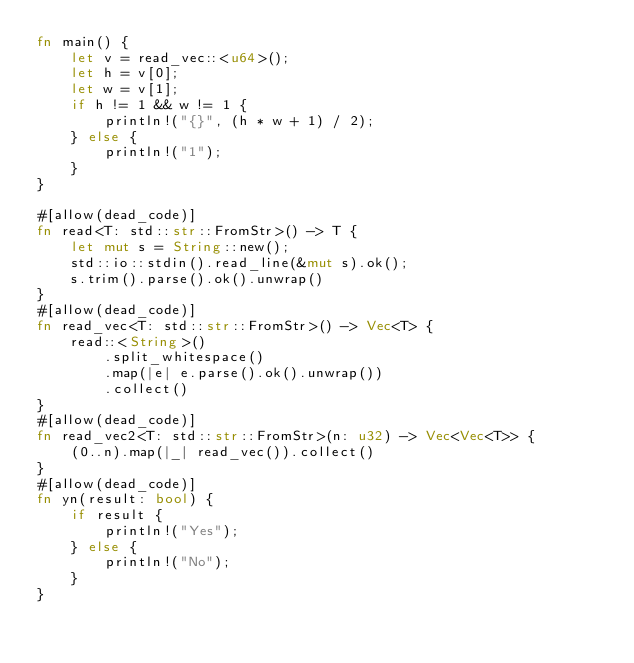<code> <loc_0><loc_0><loc_500><loc_500><_Rust_>fn main() {
    let v = read_vec::<u64>();
    let h = v[0];
    let w = v[1];
    if h != 1 && w != 1 {
        println!("{}", (h * w + 1) / 2);
    } else {
        println!("1");
    }
}

#[allow(dead_code)]
fn read<T: std::str::FromStr>() -> T {
    let mut s = String::new();
    std::io::stdin().read_line(&mut s).ok();
    s.trim().parse().ok().unwrap()
}
#[allow(dead_code)]
fn read_vec<T: std::str::FromStr>() -> Vec<T> {
    read::<String>()
        .split_whitespace()
        .map(|e| e.parse().ok().unwrap())
        .collect()
}
#[allow(dead_code)]
fn read_vec2<T: std::str::FromStr>(n: u32) -> Vec<Vec<T>> {
    (0..n).map(|_| read_vec()).collect()
}
#[allow(dead_code)]
fn yn(result: bool) {
    if result {
        println!("Yes");
    } else {
        println!("No");
    }
}
</code> 